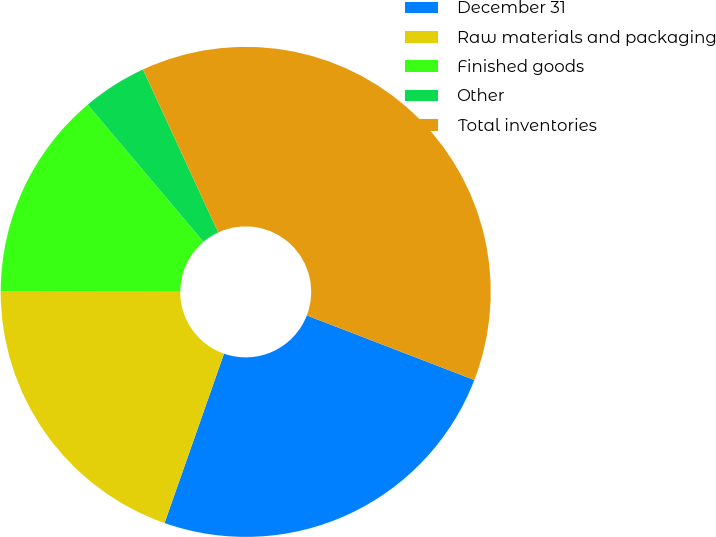Convert chart. <chart><loc_0><loc_0><loc_500><loc_500><pie_chart><fcel>December 31<fcel>Raw materials and packaging<fcel>Finished goods<fcel>Other<fcel>Total inventories<nl><fcel>24.52%<fcel>19.66%<fcel>13.81%<fcel>4.27%<fcel>37.74%<nl></chart> 